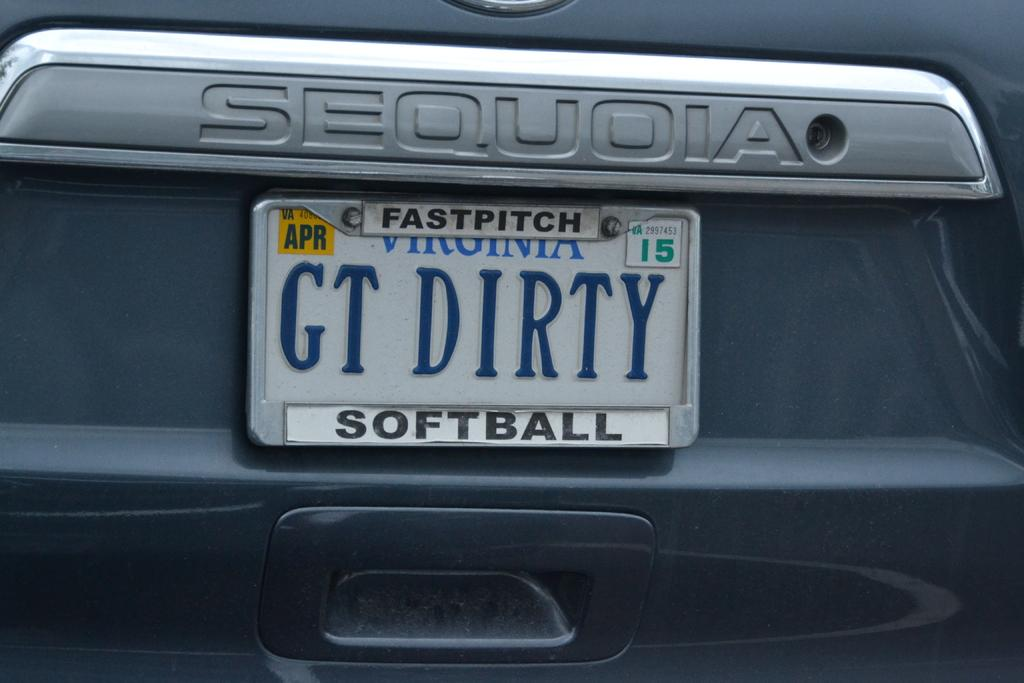Provide a one-sentence caption for the provided image. A car has a fast pitch softball license plate holder on it. 